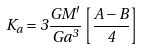Convert formula to latex. <formula><loc_0><loc_0><loc_500><loc_500>K _ { a } = 3 \frac { G M ^ { \prime } } { G a ^ { 3 } } \left [ \frac { A - B } { 4 } \right ]</formula> 